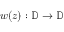Convert formula to latex. <formula><loc_0><loc_0><loc_500><loc_500>w ( z ) \colon \mathbb { D } \rightarrow \mathbb { D }</formula> 